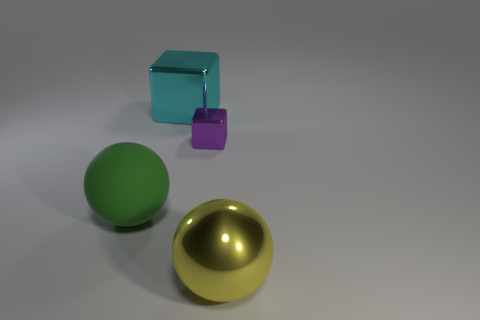What number of spheres are behind the metal sphere and right of the cyan block?
Ensure brevity in your answer.  0. How many objects are tiny purple blocks or metallic objects in front of the cyan metal thing?
Your response must be concise. 2. There is a ball that is in front of the rubber sphere; what color is it?
Keep it short and to the point. Yellow. How many things are balls on the right side of the purple shiny block or large green balls?
Your answer should be compact. 2. There is a rubber thing that is the same size as the metal ball; what color is it?
Provide a short and direct response. Green. Are there more cyan objects that are to the left of the big cyan shiny thing than big cubes?
Your response must be concise. No. There is a thing that is behind the large matte sphere and left of the small purple block; what material is it?
Provide a short and direct response. Metal. Is the color of the large metallic object that is on the right side of the tiny block the same as the large metallic thing behind the green thing?
Ensure brevity in your answer.  No. What number of other things are there of the same size as the yellow ball?
Offer a terse response. 2. There is a big green sphere that is on the left side of the large sphere that is on the right side of the tiny purple metal thing; are there any yellow balls that are behind it?
Ensure brevity in your answer.  No. 